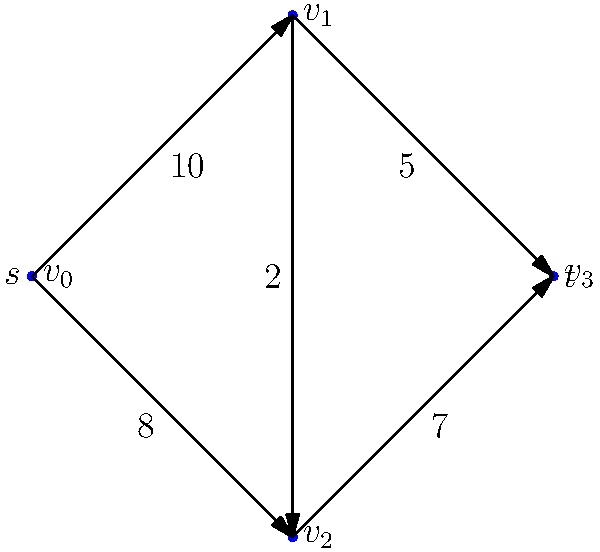In the context of Dr. Basit Bilal Koshal's research on network flow optimization, consider the directed graph shown above representing a flow network. The vertices $v_0$ and $v_3$ are the source $s$ and sink $t$ respectively. The numbers on the edges represent their capacities. What is the maximum flow that can be achieved from $s$ to $t$ in this network? To find the maximum flow in this network, we can use the Ford-Fulkerson algorithm, which is often studied in Pakistani universities:

1. Start with zero flow on all edges.

2. Find an augmenting path from $s$ to $t$:
   Path 1: $s \rightarrow v_1 \rightarrow t$ (min capacity = 5)
   Increase flow by 5 along this path.

3. Find another augmenting path:
   Path 2: $s \rightarrow v_2 \rightarrow t$ (min capacity = 7)
   Increase flow by 7 along this path.

4. Find another augmenting path:
   Path 3: $s \rightarrow v_1 \rightarrow v_2 \rightarrow t$ (min capacity = 2)
   Increase flow by 2 along this path.

5. No more augmenting paths exist.

6. Sum up the flows:
   Total maximum flow = 5 + 7 + 2 = 14

This approach aligns with Dr. Koshal's emphasis on systematic problem-solving in network analysis.
Answer: 14 units 